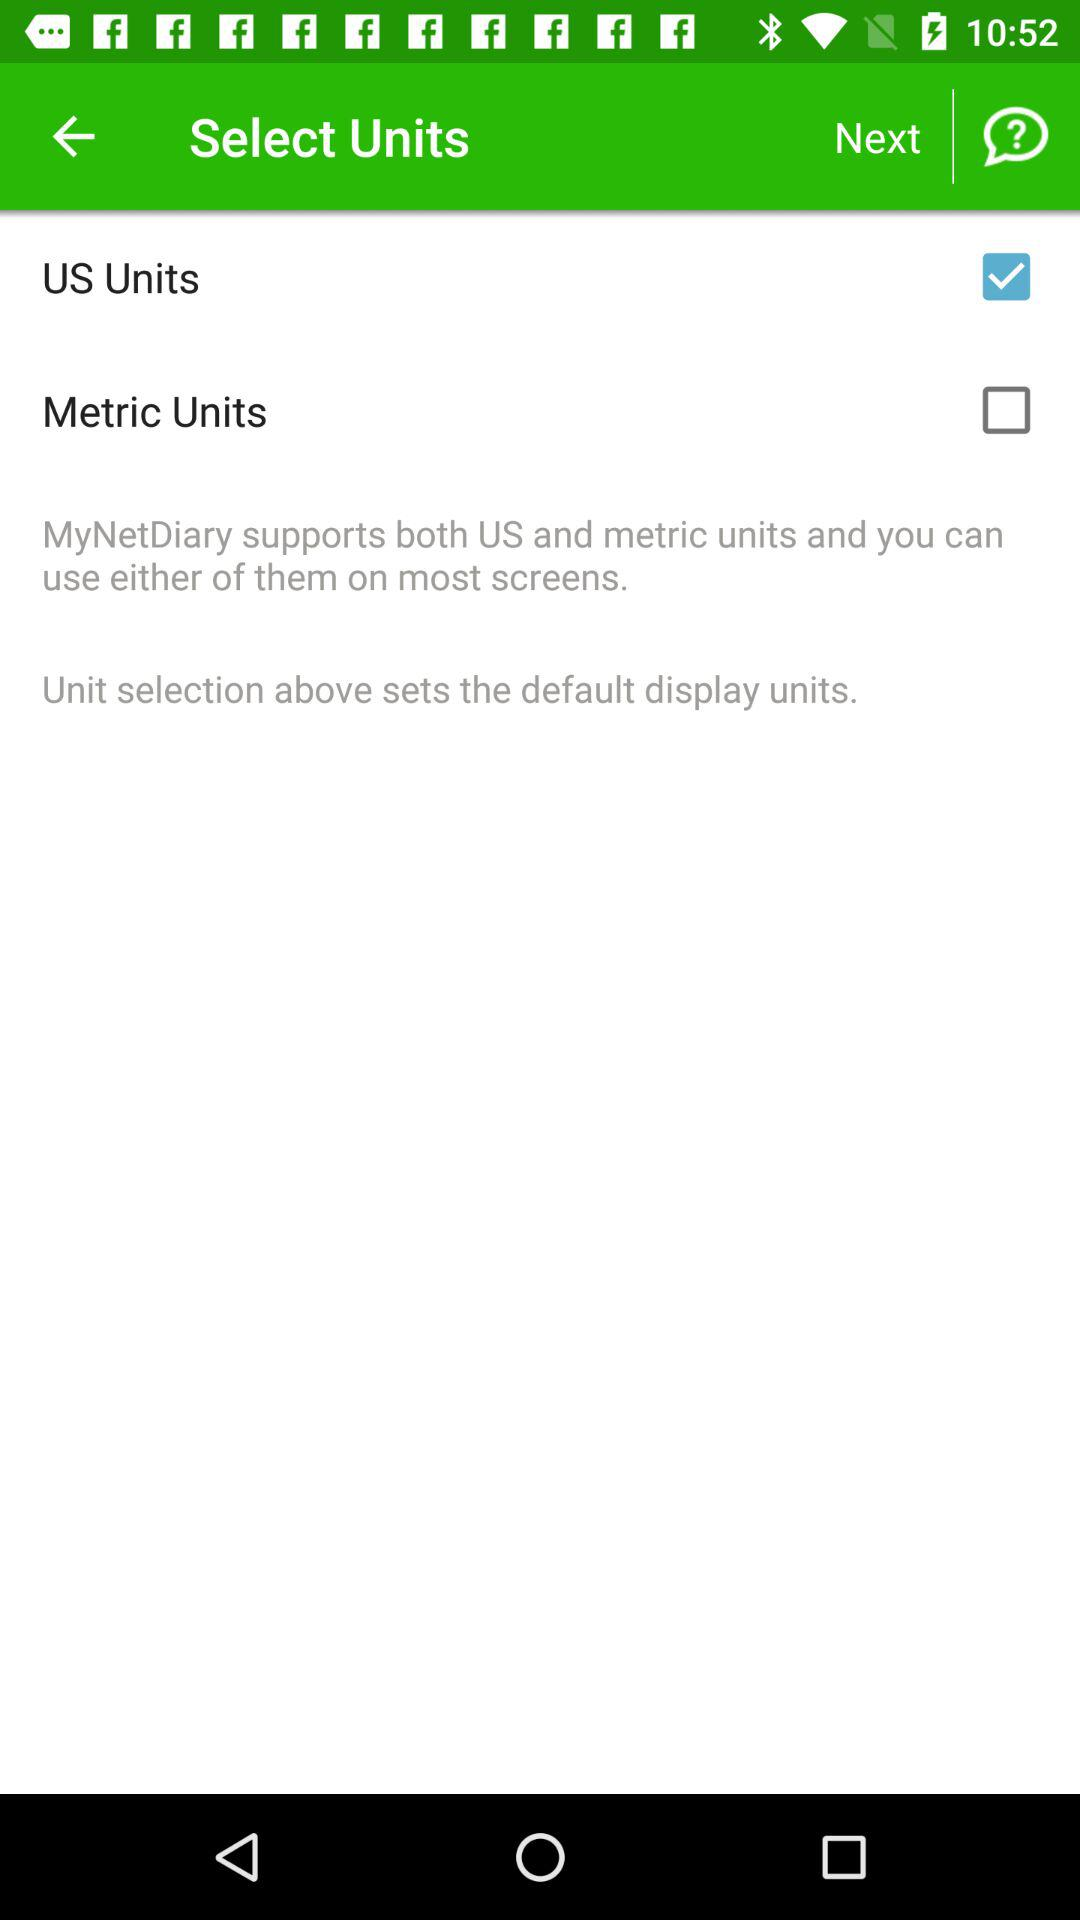What is the name of the application? The name of the application is "MyNetDiary". 